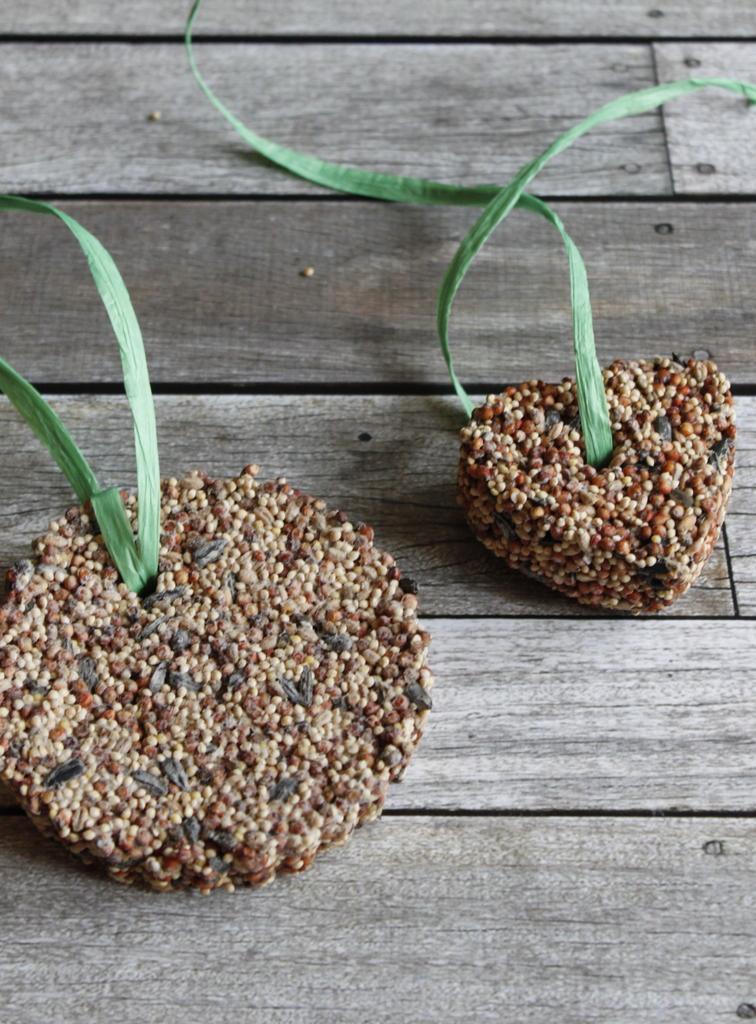How would you summarize this image in a sentence or two? On this wooden surface there are two objects. One is in round shape and another is in heart shape. 